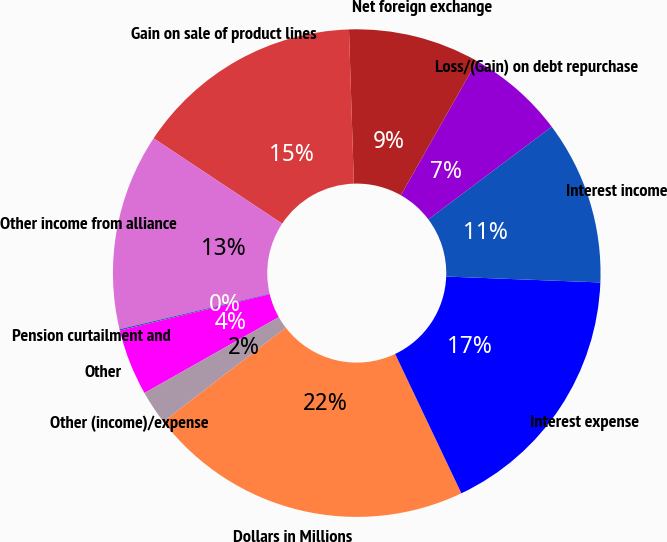<chart> <loc_0><loc_0><loc_500><loc_500><pie_chart><fcel>Dollars in Millions<fcel>Interest expense<fcel>Interest income<fcel>Loss/(Gain) on debt repurchase<fcel>Net foreign exchange<fcel>Gain on sale of product lines<fcel>Other income from alliance<fcel>Pension curtailment and<fcel>Other<fcel>Other (income)/expense<nl><fcel>21.64%<fcel>17.33%<fcel>10.86%<fcel>6.55%<fcel>8.71%<fcel>15.17%<fcel>13.02%<fcel>0.09%<fcel>4.4%<fcel>2.24%<nl></chart> 